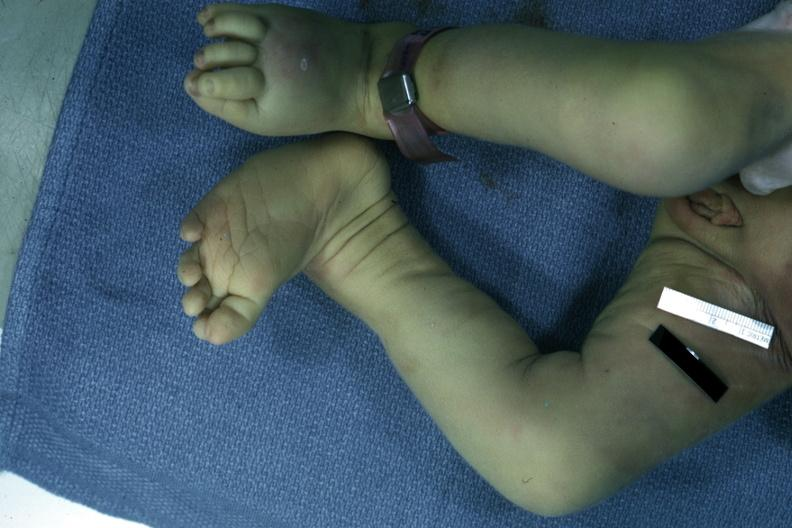does aldehyde fuscin show autopsy left club foot?
Answer the question using a single word or phrase. No 